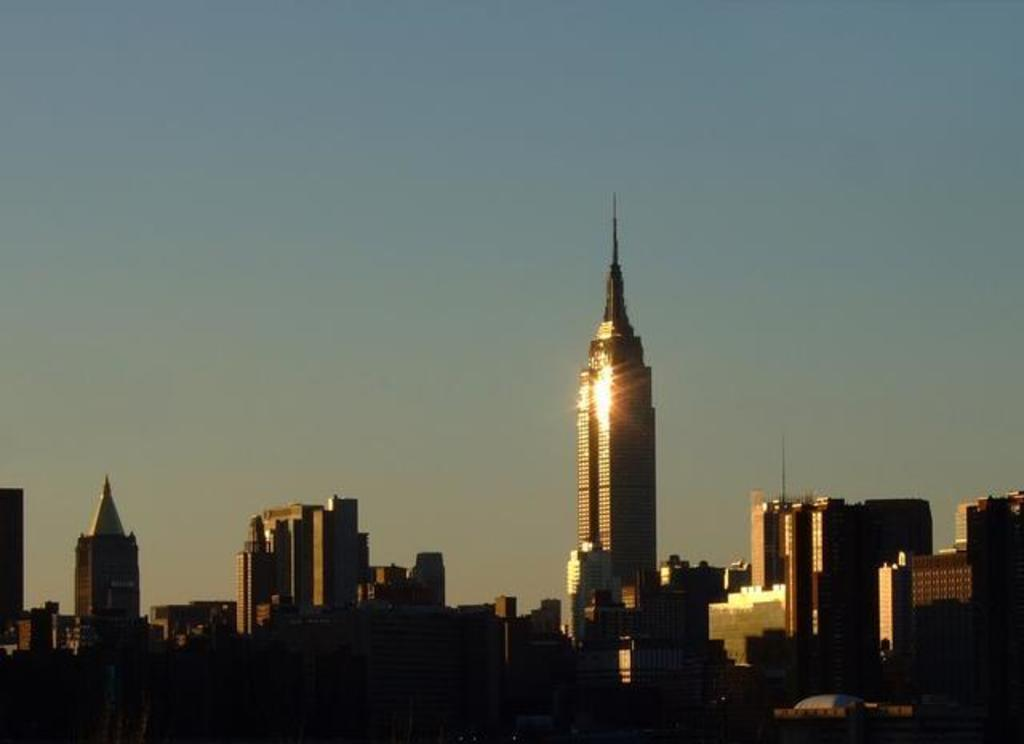What type of structures can be seen in the picture? There are buildings in the picture. What is the condition of the sky in the picture? The sky is clear in the picture. Who gave your sister a haircut in the picture? There is no sister or haircut present in the picture; it only features buildings and a clear sky. Is there a baseball game happening in the picture? There is no baseball game or any reference to sports in the picture; it only features buildings and a clear sky. 